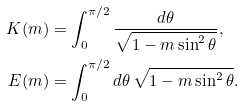<formula> <loc_0><loc_0><loc_500><loc_500>K ( m ) & = \int _ { 0 } ^ { \pi / 2 } \frac { d \theta } { \sqrt { 1 - m \sin ^ { 2 } \theta } } , \\ E ( m ) & = \int _ { 0 } ^ { \pi / 2 } d \theta \, \sqrt { 1 - m \sin ^ { 2 } \theta } .</formula> 